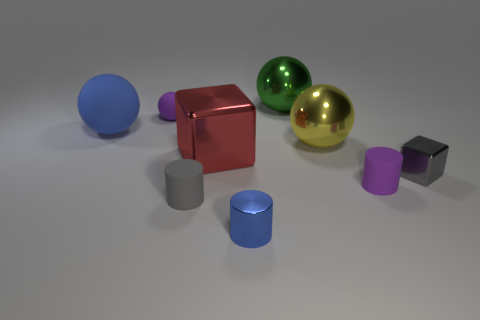Subtract all big green metal balls. How many balls are left? 3 Subtract all blue cylinders. How many cylinders are left? 2 Subtract all cylinders. How many objects are left? 6 Subtract 2 spheres. How many spheres are left? 2 Subtract all green cylinders. How many blue spheres are left? 1 Subtract all yellow objects. Subtract all blue metallic cylinders. How many objects are left? 7 Add 5 big metal blocks. How many big metal blocks are left? 6 Add 6 blue matte objects. How many blue matte objects exist? 7 Add 1 purple matte things. How many objects exist? 10 Subtract 1 purple balls. How many objects are left? 8 